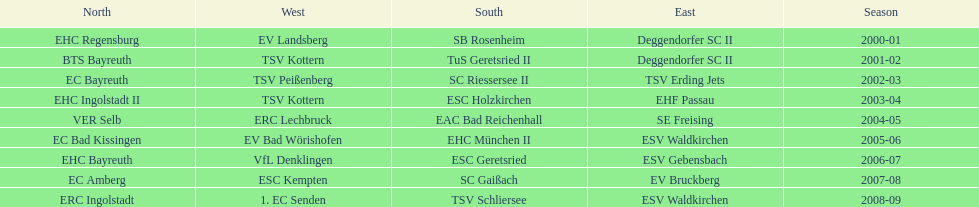Which name appears more often, kottern or bayreuth? Bayreuth. 